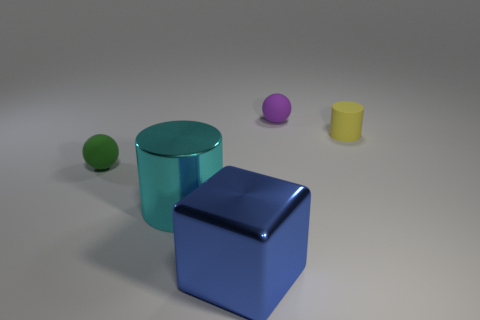Are any big yellow metallic cubes visible?
Give a very brief answer. No. Is there anything else that is the same shape as the purple rubber object?
Your response must be concise. Yes. Are there more large cyan metal things behind the shiny cylinder than large blue metal blocks?
Provide a short and direct response. No. There is a large cylinder; are there any tiny green things right of it?
Make the answer very short. No. Is the purple thing the same size as the blue block?
Provide a succinct answer. No. What size is the yellow thing that is the same shape as the large cyan metallic thing?
Ensure brevity in your answer.  Small. What material is the ball that is behind the matte thing to the left of the purple thing?
Your answer should be compact. Rubber. Is the purple matte object the same shape as the big blue metallic object?
Provide a succinct answer. No. What number of things are both right of the big cyan object and in front of the yellow rubber thing?
Give a very brief answer. 1. Is the number of small yellow cylinders to the left of the metallic block the same as the number of tiny spheres left of the small green rubber thing?
Make the answer very short. Yes. 